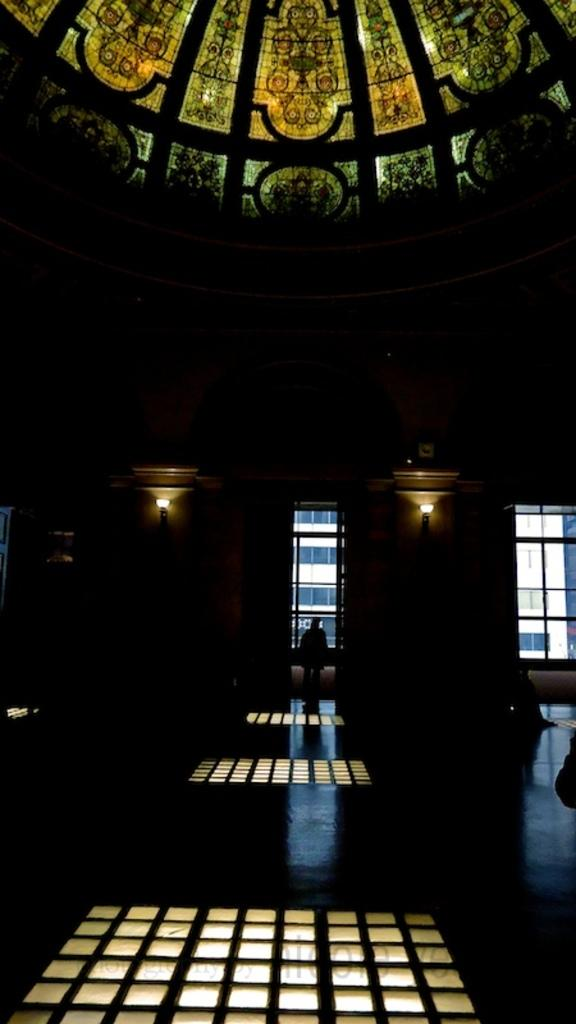What is placed on the floor in the image? There are lights on the floor in the image. What type of lighting is attached to the wall in the image? There are lamps attached to the wall in the image. Can you describe the person in the image? There is a person standing in the image. What can be seen through the windows in the image? Windows are visible in the image. What is visible in the background of the image? There is a building in the background of the image. What type of produce is being weighed on the scale in the image? There is no produce or scale present in the image. Can you describe the robin perched on the windowsill in the image? There is no robin present in the image. 